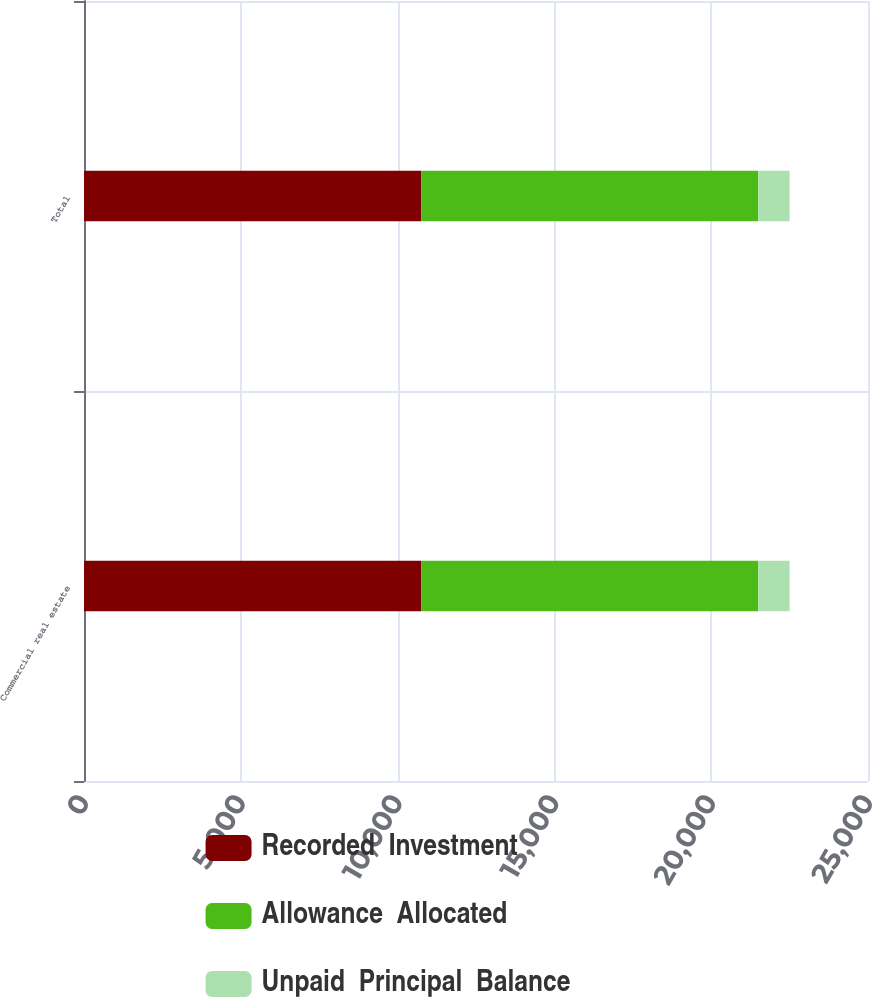Convert chart. <chart><loc_0><loc_0><loc_500><loc_500><stacked_bar_chart><ecel><fcel>Commercial real estate<fcel>Total<nl><fcel>Recorded  Investment<fcel>10750<fcel>10750<nl><fcel>Allowance  Allocated<fcel>10750<fcel>10750<nl><fcel>Unpaid  Principal  Balance<fcel>1000<fcel>1000<nl></chart> 